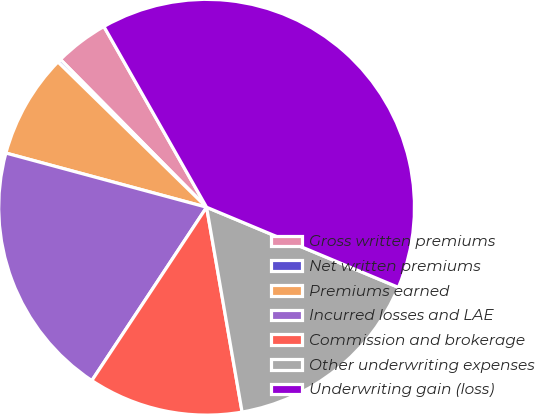Convert chart to OTSL. <chart><loc_0><loc_0><loc_500><loc_500><pie_chart><fcel>Gross written premiums<fcel>Net written premiums<fcel>Premiums earned<fcel>Incurred losses and LAE<fcel>Commission and brokerage<fcel>Other underwriting expenses<fcel>Underwriting gain (loss)<nl><fcel>4.19%<fcel>0.27%<fcel>8.12%<fcel>19.89%<fcel>12.04%<fcel>15.97%<fcel>39.52%<nl></chart> 